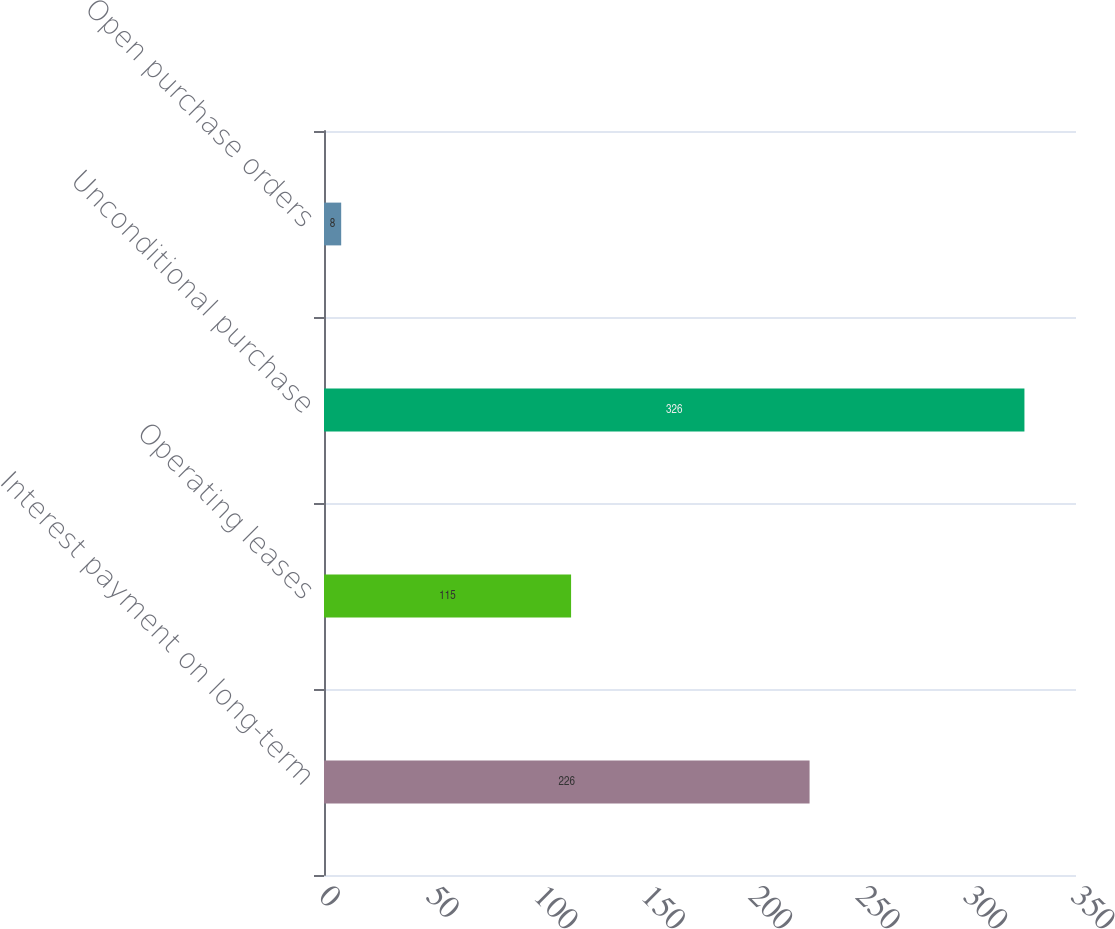Convert chart. <chart><loc_0><loc_0><loc_500><loc_500><bar_chart><fcel>Interest payment on long-term<fcel>Operating leases<fcel>Unconditional purchase<fcel>Open purchase orders<nl><fcel>226<fcel>115<fcel>326<fcel>8<nl></chart> 